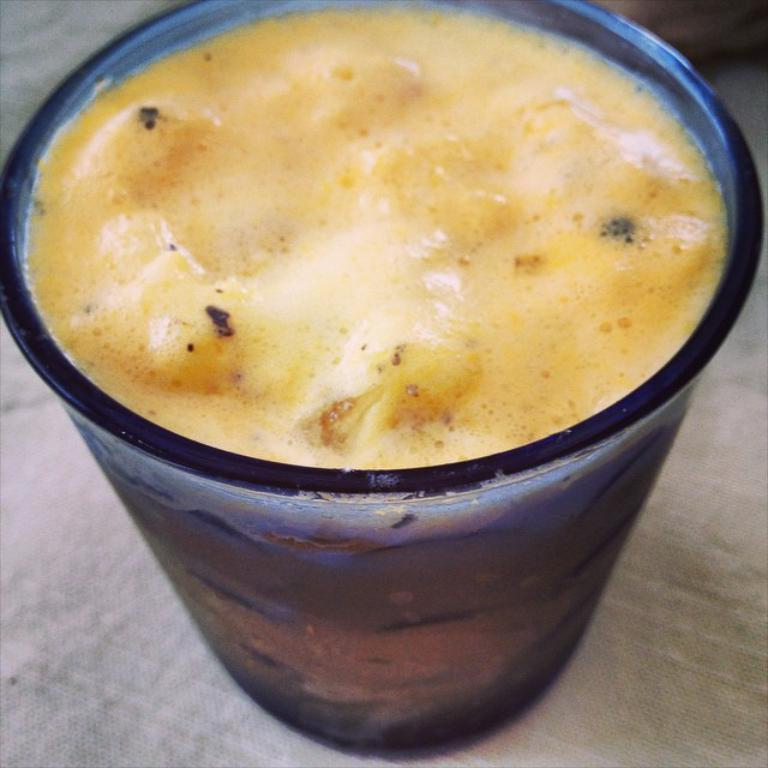What is in the glass that is visible in the image? The glass contains a drink. Where is the glass located in the image? The glass is placed on a surface. What type of door can be seen in the image? There is no door present in the image; it only features a glass with a drink on a surface. 